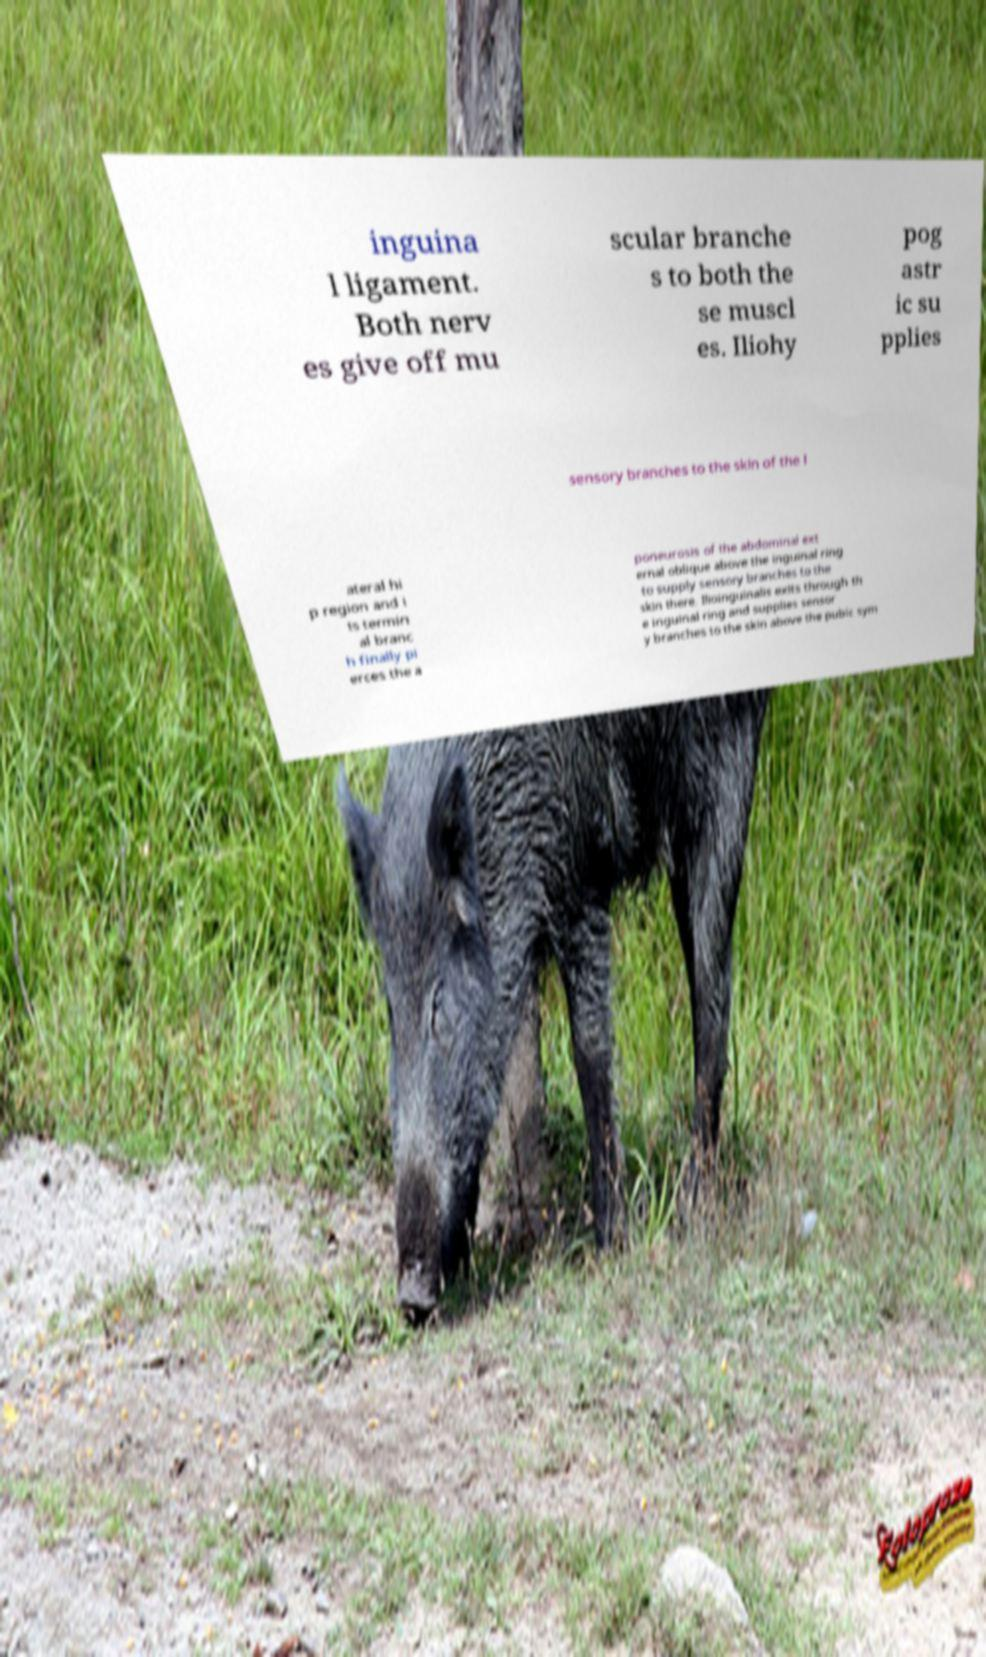What messages or text are displayed in this image? I need them in a readable, typed format. inguina l ligament. Both nerv es give off mu scular branche s to both the se muscl es. Iliohy pog astr ic su pplies sensory branches to the skin of the l ateral hi p region and i ts termin al branc h finally pi erces the a poneurosis of the abdominal ext ernal oblique above the inguinal ring to supply sensory branches to the skin there. Ilioinguinalis exits through th e inguinal ring and supplies sensor y branches to the skin above the pubic sym 